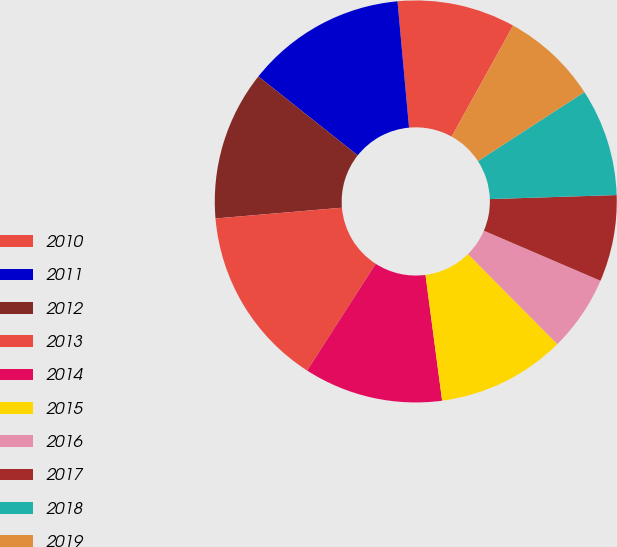Convert chart. <chart><loc_0><loc_0><loc_500><loc_500><pie_chart><fcel>2010<fcel>2011<fcel>2012<fcel>2013<fcel>2014<fcel>2015<fcel>2016<fcel>2017<fcel>2018<fcel>2019<nl><fcel>9.49%<fcel>12.87%<fcel>12.03%<fcel>14.56%<fcel>11.18%<fcel>10.34%<fcel>6.11%<fcel>6.96%<fcel>8.65%<fcel>7.8%<nl></chart> 